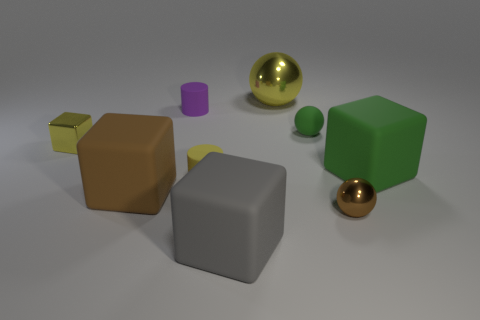Is the color of the big metallic thing the same as the tiny shiny thing right of the brown matte cube?
Offer a very short reply. No. Are there more big gray cubes in front of the gray block than big gray cubes?
Your response must be concise. No. What number of things are either small matte things that are on the right side of the big shiny object or balls that are in front of the matte ball?
Your answer should be compact. 2. There is another cylinder that is the same material as the small purple cylinder; what size is it?
Ensure brevity in your answer.  Small. Does the big matte thing that is in front of the tiny brown ball have the same shape as the tiny brown metallic thing?
Offer a terse response. No. What is the size of the rubber cylinder that is the same color as the tiny block?
Provide a short and direct response. Small. How many gray objects are small balls or cylinders?
Make the answer very short. 0. How many other things are the same shape as the large yellow thing?
Offer a very short reply. 2. There is a metal object that is both in front of the tiny green sphere and right of the metal block; what shape is it?
Ensure brevity in your answer.  Sphere. There is a tiny yellow shiny object; are there any large gray matte blocks left of it?
Ensure brevity in your answer.  No. 